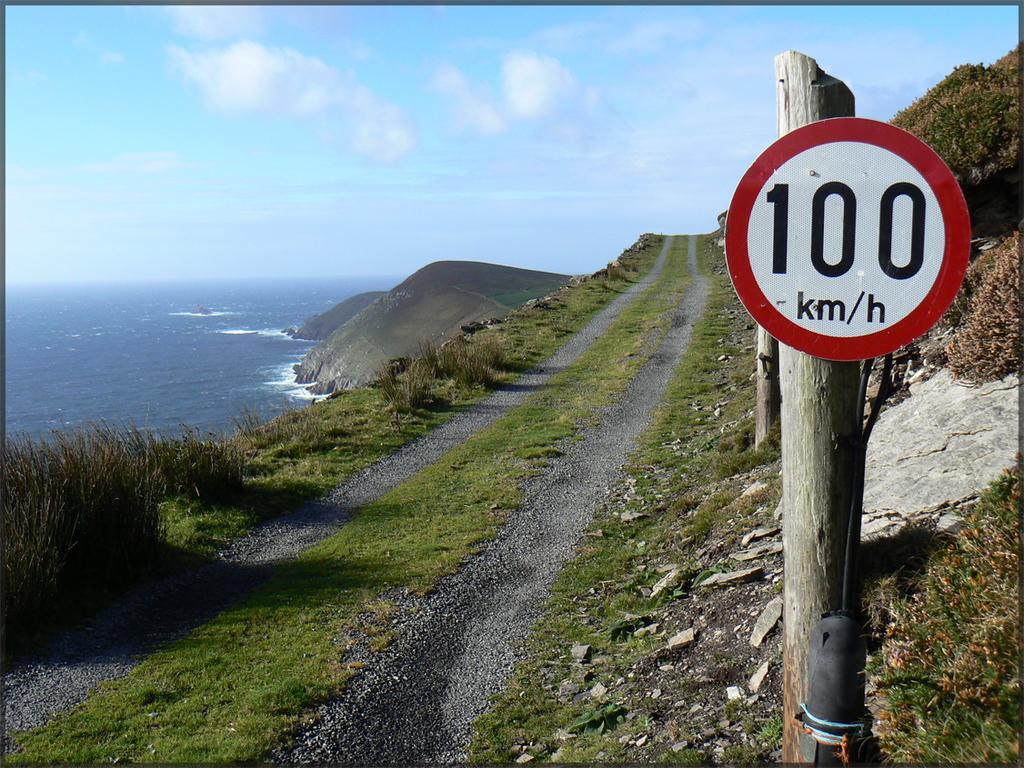<image>
Share a concise interpretation of the image provided. A two track gravel lane with a sign saying there is a limit of 100 km per hour. 